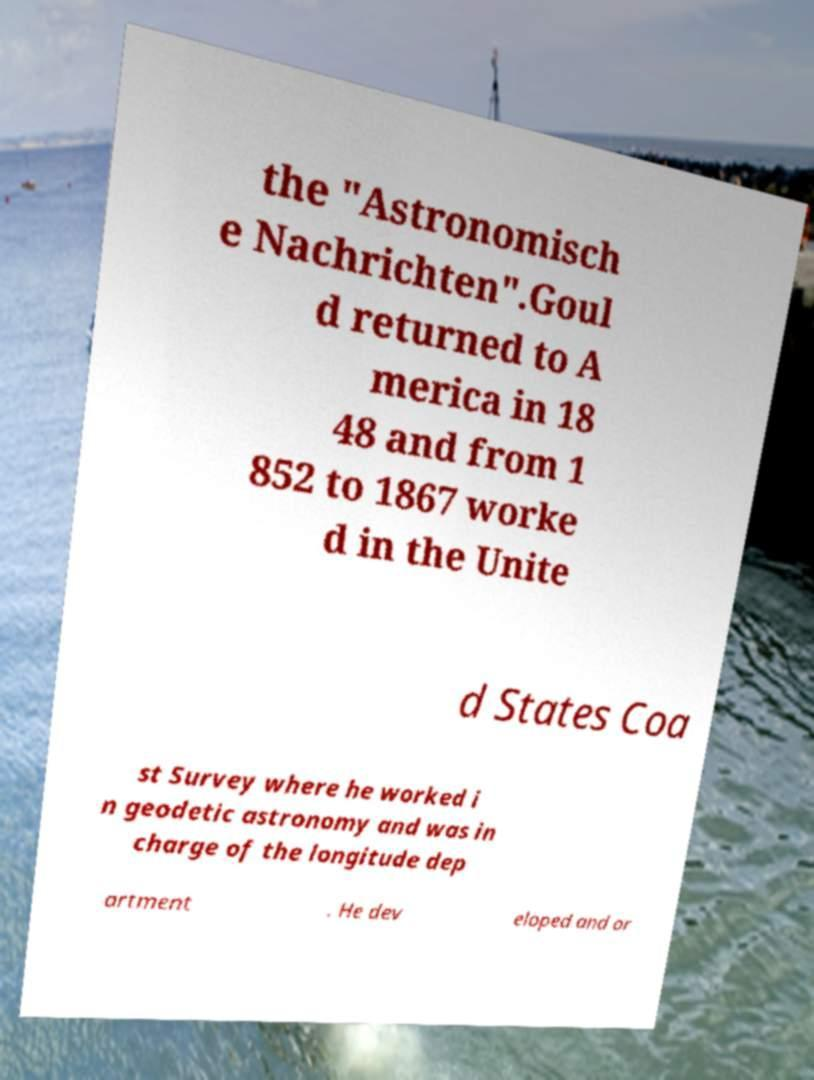What messages or text are displayed in this image? I need them in a readable, typed format. the "Astronomisch e Nachrichten".Goul d returned to A merica in 18 48 and from 1 852 to 1867 worke d in the Unite d States Coa st Survey where he worked i n geodetic astronomy and was in charge of the longitude dep artment . He dev eloped and or 